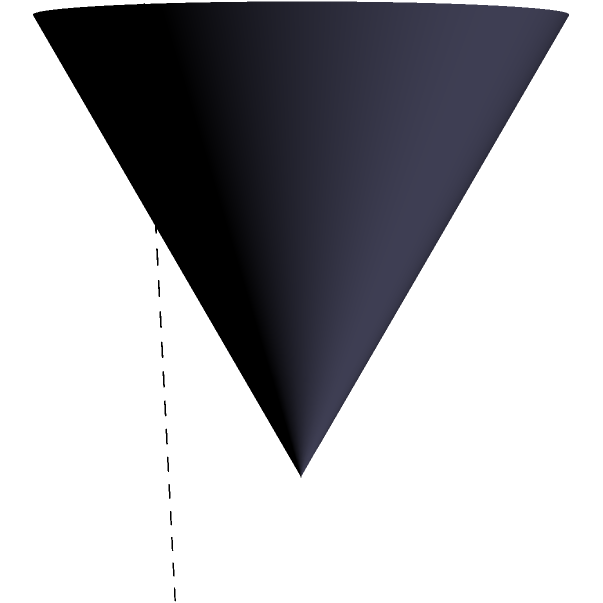A cone-shaped speaker has a radius of 2 inches and a height of 4 inches. If the volume of the speaker cone is doubled while maintaining the same radius, how does this affect the height of the cone? Express your answer in terms of the original height. Let's approach this step-by-step:

1) The volume of a cone is given by the formula:
   $$V = \frac{1}{3}\pi r^2 h$$
   where $r$ is the radius and $h$ is the height.

2) Initially, we have:
   $$V_1 = \frac{1}{3}\pi (2^2) (4) = \frac{16}{3}\pi$$

3) When we double the volume, we get:
   $$V_2 = 2V_1 = 2(\frac{16}{3}\pi) = \frac{32}{3}\pi$$

4) Now, we need to find the new height $h_2$ that gives us this doubled volume while keeping the radius the same:
   $$\frac{32}{3}\pi = \frac{1}{3}\pi (2^2) (h_2)$$

5) Simplifying:
   $$32 = 4h_2$$

6) Solving for $h_2$:
   $$h_2 = 8$$

7) Comparing to the original height:
   $$h_2 = 8 = 2 * 4 = 2h_1$$

Therefore, doubling the volume while maintaining the same radius results in doubling the height of the cone.
Answer: $2h$ 